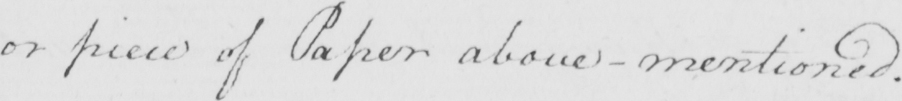What does this handwritten line say? or piece of Paper above-mentioned . 